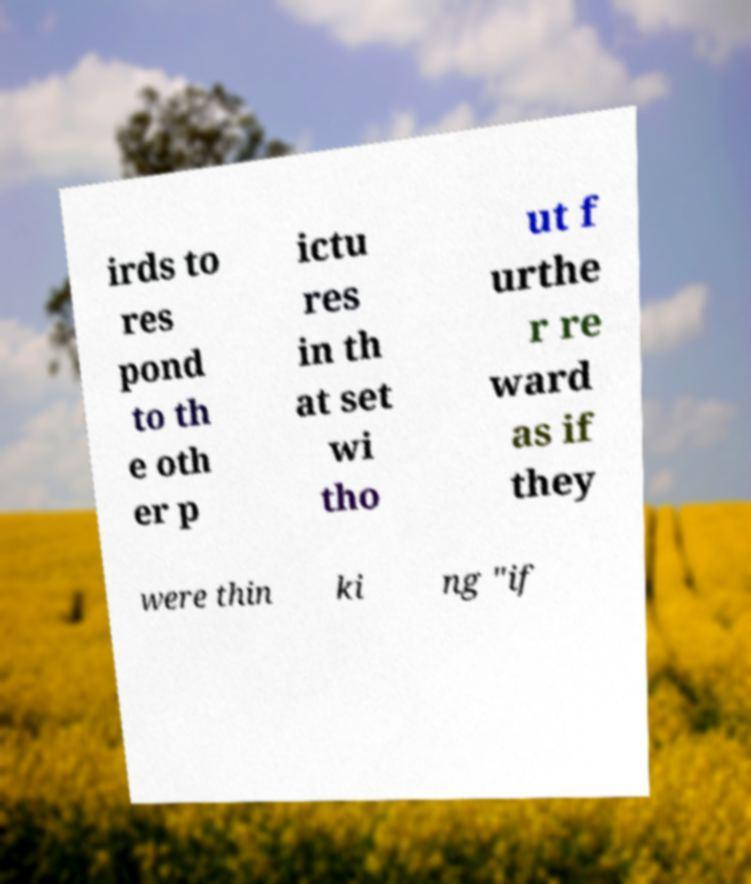For documentation purposes, I need the text within this image transcribed. Could you provide that? irds to res pond to th e oth er p ictu res in th at set wi tho ut f urthe r re ward as if they were thin ki ng "if 